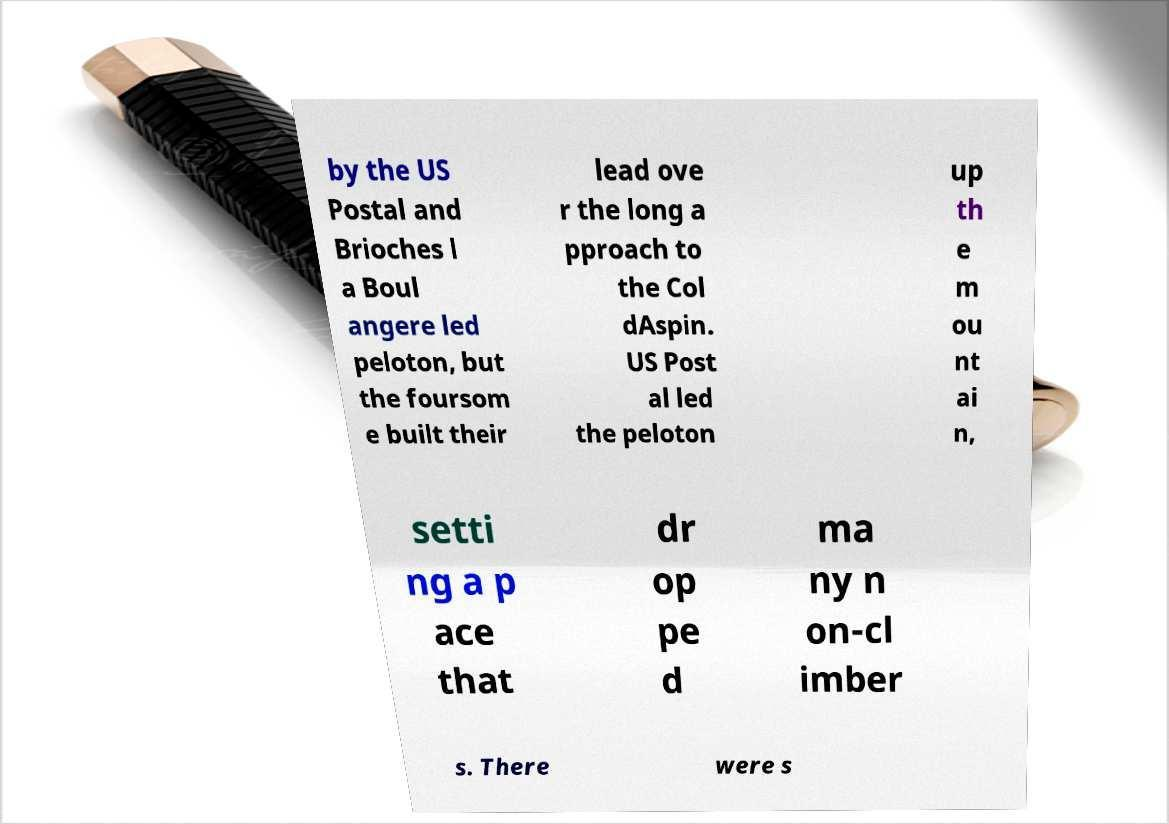Please read and relay the text visible in this image. What does it say? by the US Postal and Brioches l a Boul angere led peloton, but the foursom e built their lead ove r the long a pproach to the Col dAspin. US Post al led the peloton up th e m ou nt ai n, setti ng a p ace that dr op pe d ma ny n on-cl imber s. There were s 